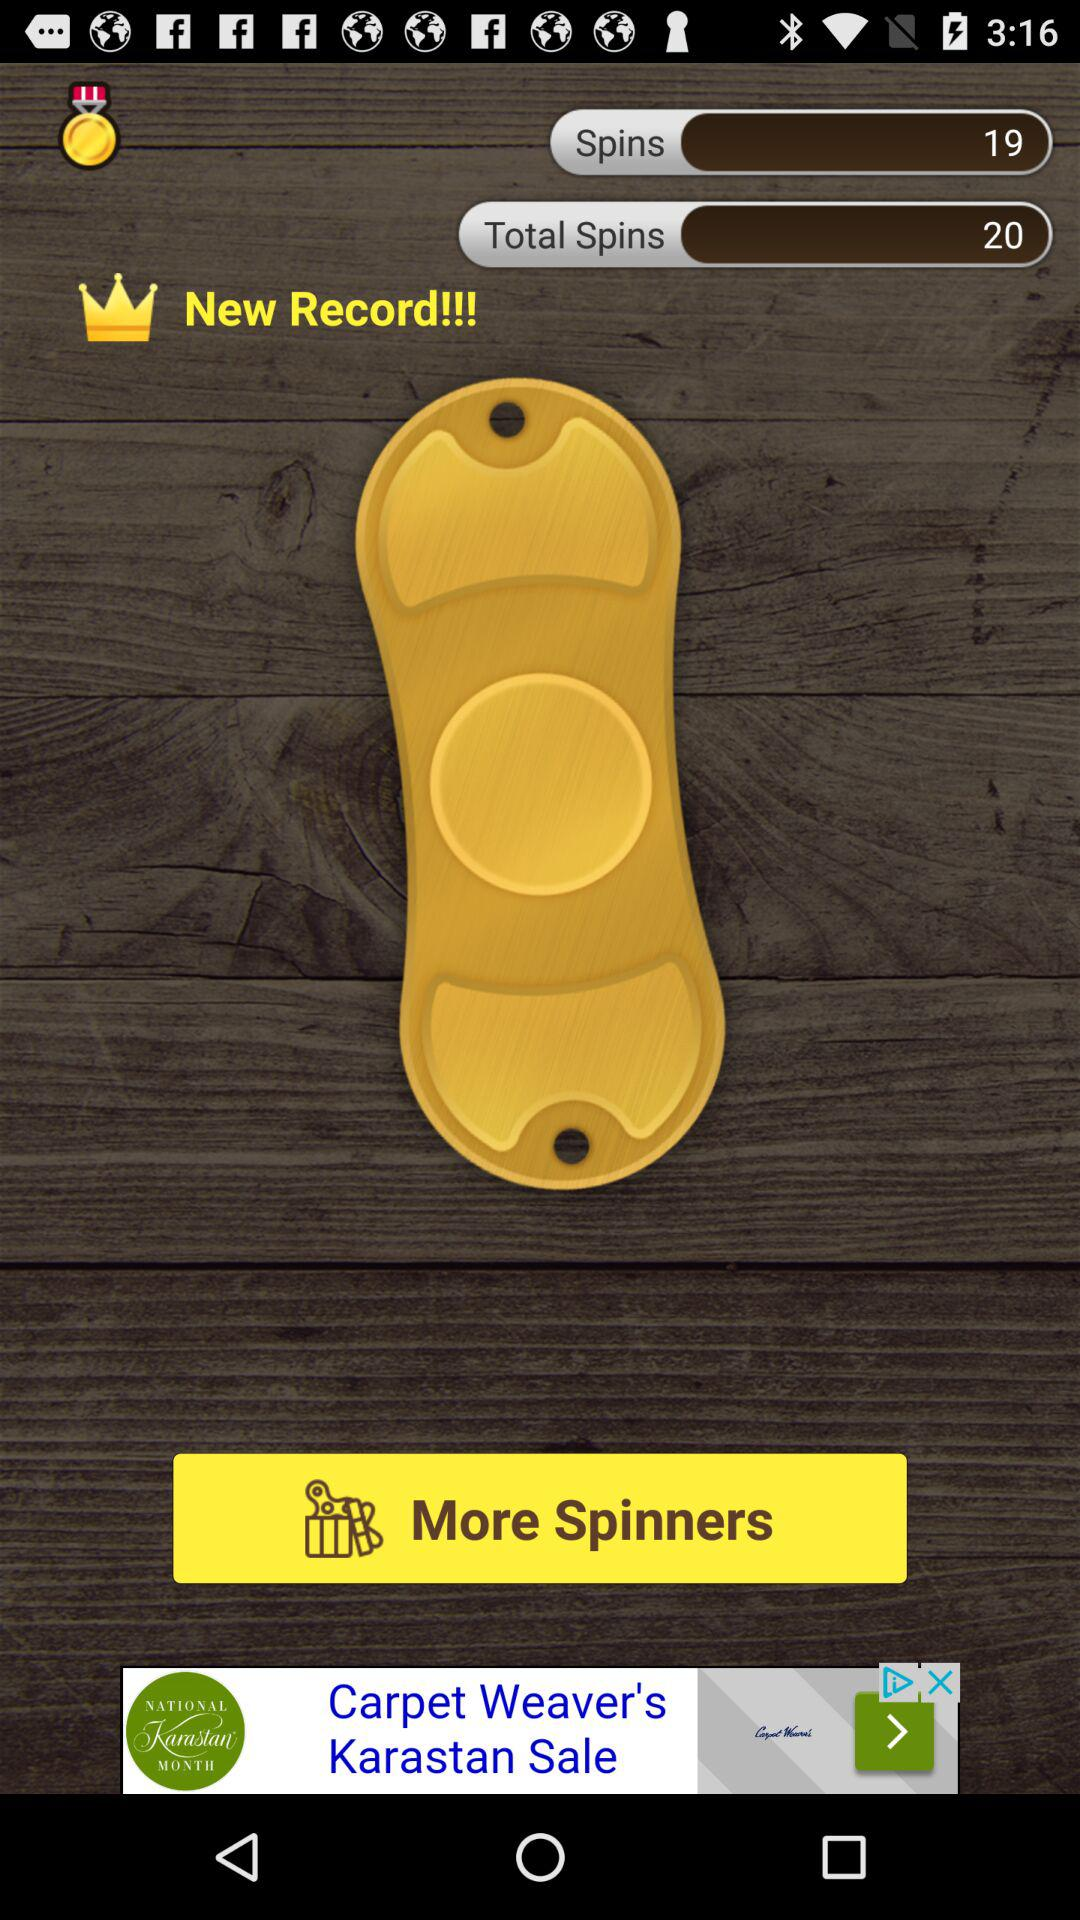How many more spins do I need to get to 20?
Answer the question using a single word or phrase. 1 